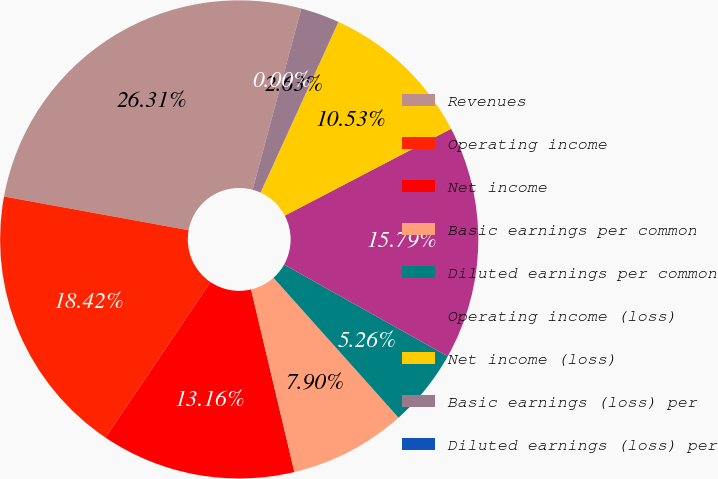Convert chart. <chart><loc_0><loc_0><loc_500><loc_500><pie_chart><fcel>Revenues<fcel>Operating income<fcel>Net income<fcel>Basic earnings per common<fcel>Diluted earnings per common<fcel>Operating income (loss)<fcel>Net income (loss)<fcel>Basic earnings (loss) per<fcel>Diluted earnings (loss) per<nl><fcel>26.31%<fcel>18.42%<fcel>13.16%<fcel>7.9%<fcel>5.26%<fcel>15.79%<fcel>10.53%<fcel>2.63%<fcel>0.0%<nl></chart> 